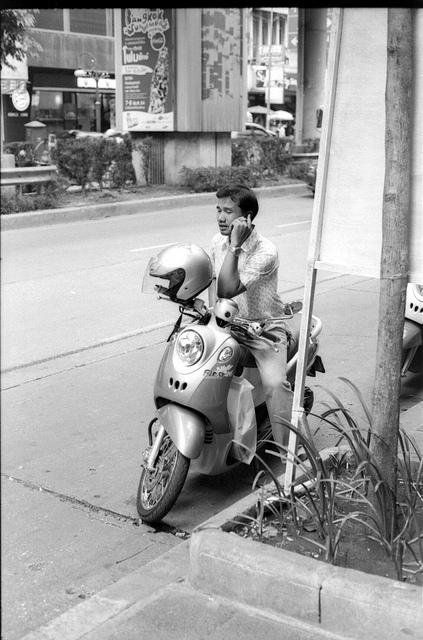What has the man stopped on his scooter?

Choices:
A) accident
B) traffic
C) floods
D) phone call phone call 